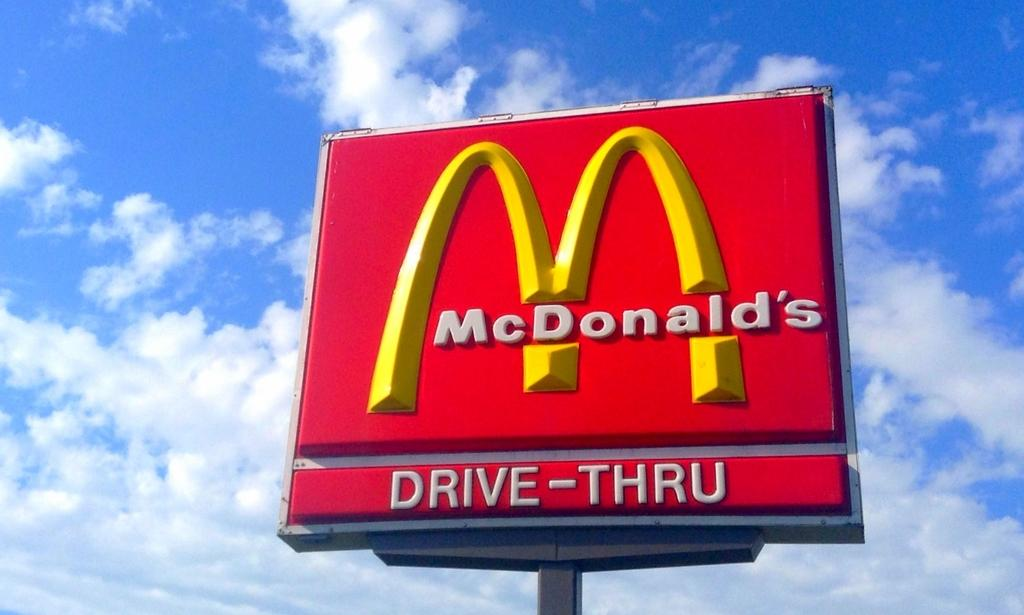<image>
Share a concise interpretation of the image provided. A McDonald's sign is shown with the golden arches and a Drive-Thru sign. 